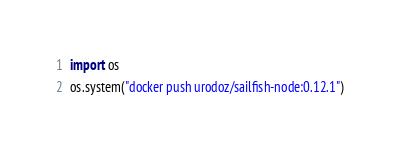Convert code to text. <code><loc_0><loc_0><loc_500><loc_500><_Python_>import os
os.system("docker push urodoz/sailfish-node:0.12.1")</code> 